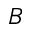Convert formula to latex. <formula><loc_0><loc_0><loc_500><loc_500>B</formula> 